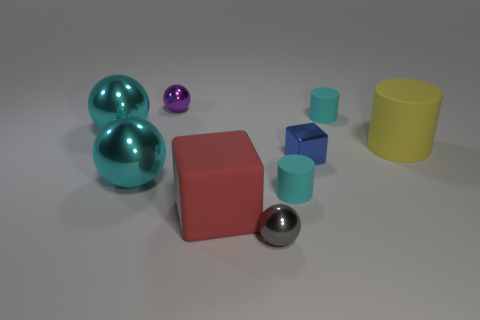Is there anything else that is made of the same material as the big yellow thing?
Your response must be concise. Yes. The tiny object that is both behind the big matte cylinder and in front of the tiny purple metallic object is made of what material?
Your answer should be compact. Rubber. There is a gray object that is made of the same material as the small purple thing; what shape is it?
Keep it short and to the point. Sphere. Is there any other thing of the same color as the big rubber cylinder?
Make the answer very short. No. Are there more big red things in front of the yellow cylinder than large brown metallic cylinders?
Offer a terse response. Yes. What material is the large red cube?
Give a very brief answer. Rubber. How many purple things are the same size as the blue block?
Your answer should be very brief. 1. Is the number of small spheres that are on the left side of the small metal cube the same as the number of tiny metallic objects left of the gray thing?
Your answer should be very brief. No. Is the material of the tiny cube the same as the tiny gray sphere?
Make the answer very short. Yes. There is a rubber cylinder in front of the yellow matte cylinder; is there a tiny thing left of it?
Give a very brief answer. Yes. 